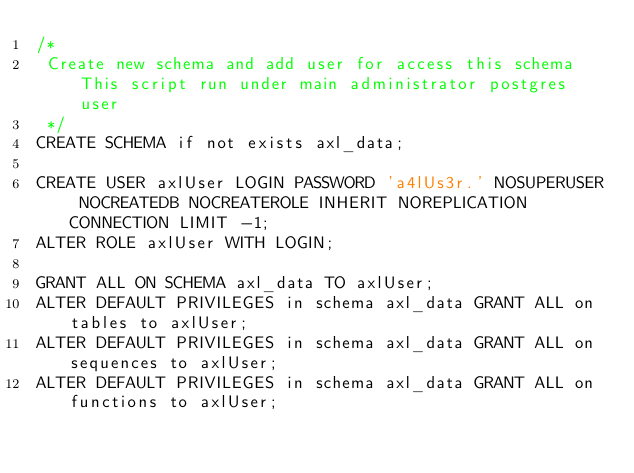Convert code to text. <code><loc_0><loc_0><loc_500><loc_500><_SQL_>/*
 Create new schema and add user for access this schema This script run under main administrator postgres user
 */
CREATE SCHEMA if not exists axl_data;

CREATE USER axlUser LOGIN PASSWORD 'a4lUs3r.' NOSUPERUSER NOCREATEDB NOCREATEROLE INHERIT NOREPLICATION CONNECTION LIMIT -1;
ALTER ROLE axlUser WITH LOGIN;

GRANT ALL ON SCHEMA axl_data TO axlUser;
ALTER DEFAULT PRIVILEGES in schema axl_data GRANT ALL on tables to axlUser;
ALTER DEFAULT PRIVILEGES in schema axl_data GRANT ALL on sequences to axlUser;
ALTER DEFAULT PRIVILEGES in schema axl_data GRANT ALL on functions to axlUser;
</code> 